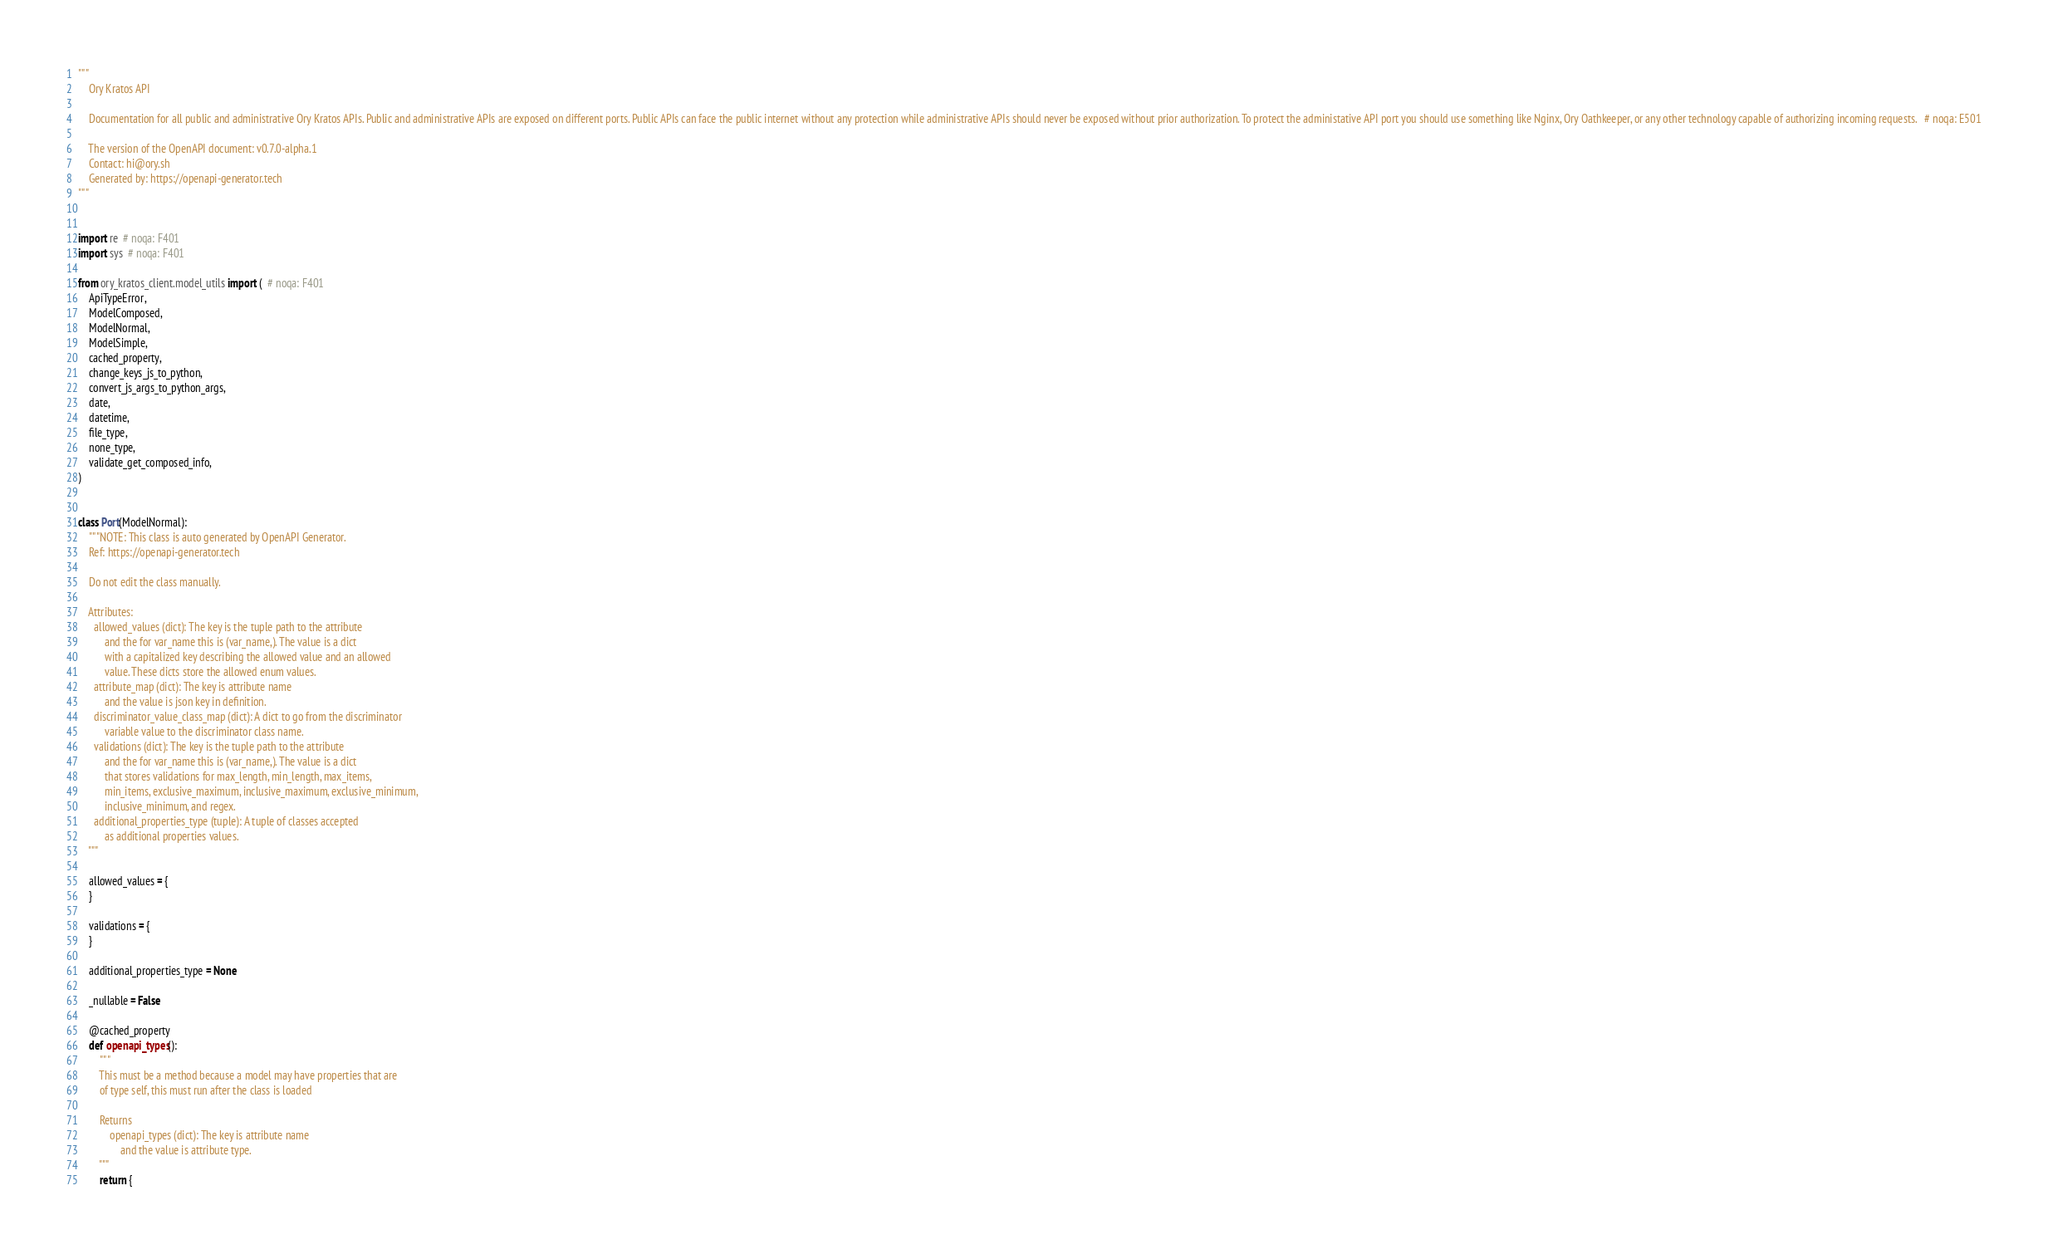Convert code to text. <code><loc_0><loc_0><loc_500><loc_500><_Python_>"""
    Ory Kratos API

    Documentation for all public and administrative Ory Kratos APIs. Public and administrative APIs are exposed on different ports. Public APIs can face the public internet without any protection while administrative APIs should never be exposed without prior authorization. To protect the administative API port you should use something like Nginx, Ory Oathkeeper, or any other technology capable of authorizing incoming requests.   # noqa: E501

    The version of the OpenAPI document: v0.7.0-alpha.1
    Contact: hi@ory.sh
    Generated by: https://openapi-generator.tech
"""


import re  # noqa: F401
import sys  # noqa: F401

from ory_kratos_client.model_utils import (  # noqa: F401
    ApiTypeError,
    ModelComposed,
    ModelNormal,
    ModelSimple,
    cached_property,
    change_keys_js_to_python,
    convert_js_args_to_python_args,
    date,
    datetime,
    file_type,
    none_type,
    validate_get_composed_info,
)


class Port(ModelNormal):
    """NOTE: This class is auto generated by OpenAPI Generator.
    Ref: https://openapi-generator.tech

    Do not edit the class manually.

    Attributes:
      allowed_values (dict): The key is the tuple path to the attribute
          and the for var_name this is (var_name,). The value is a dict
          with a capitalized key describing the allowed value and an allowed
          value. These dicts store the allowed enum values.
      attribute_map (dict): The key is attribute name
          and the value is json key in definition.
      discriminator_value_class_map (dict): A dict to go from the discriminator
          variable value to the discriminator class name.
      validations (dict): The key is the tuple path to the attribute
          and the for var_name this is (var_name,). The value is a dict
          that stores validations for max_length, min_length, max_items,
          min_items, exclusive_maximum, inclusive_maximum, exclusive_minimum,
          inclusive_minimum, and regex.
      additional_properties_type (tuple): A tuple of classes accepted
          as additional properties values.
    """

    allowed_values = {
    }

    validations = {
    }

    additional_properties_type = None

    _nullable = False

    @cached_property
    def openapi_types():
        """
        This must be a method because a model may have properties that are
        of type self, this must run after the class is loaded

        Returns
            openapi_types (dict): The key is attribute name
                and the value is attribute type.
        """
        return {</code> 